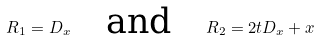Convert formula to latex. <formula><loc_0><loc_0><loc_500><loc_500>R _ { 1 } = D _ { x } \quad \text {and} \quad R _ { 2 } = 2 t D _ { x } + x</formula> 